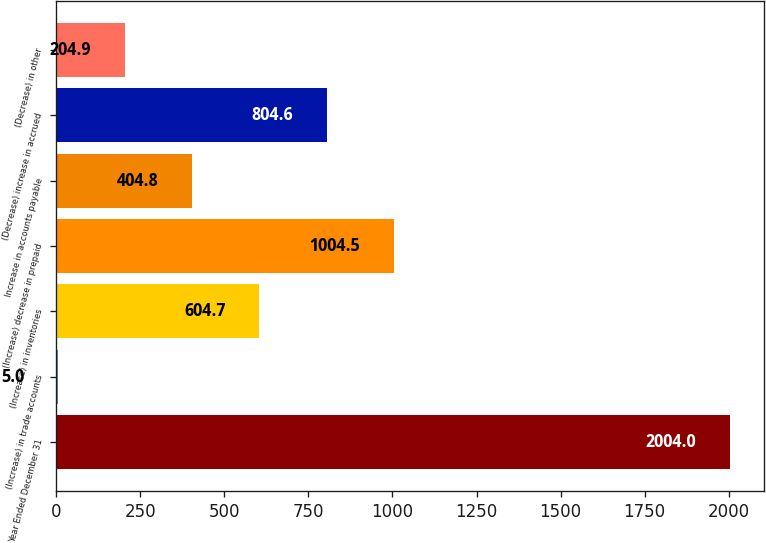Convert chart. <chart><loc_0><loc_0><loc_500><loc_500><bar_chart><fcel>Year Ended December 31<fcel>(Increase) in trade accounts<fcel>(Increase) in inventories<fcel>(Increase) decrease in prepaid<fcel>Increase in accounts payable<fcel>(Decrease) increase in accrued<fcel>(Decrease) in other<nl><fcel>2004<fcel>5<fcel>604.7<fcel>1004.5<fcel>404.8<fcel>804.6<fcel>204.9<nl></chart> 